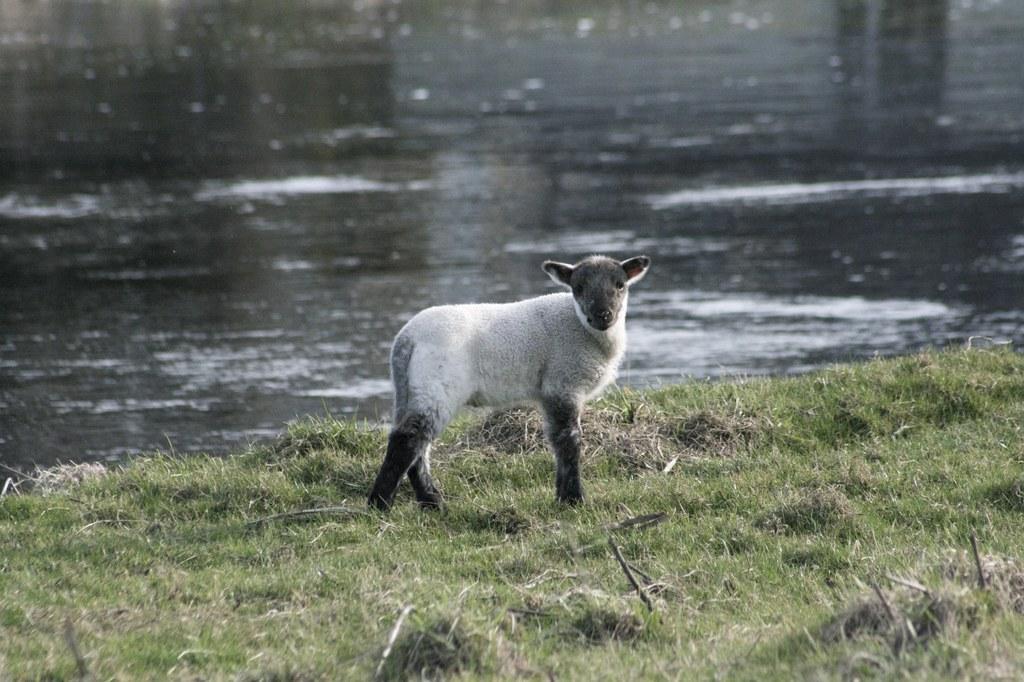Can you describe this image briefly? In this image we can see an animal on the ground. On the ground there is grass. In the back there is water. 